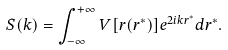<formula> <loc_0><loc_0><loc_500><loc_500>S ( k ) = \int _ { - \infty } ^ { + \infty } V [ r ( r ^ { * } ) ] e ^ { 2 i k r ^ { * } } d r ^ { * } .</formula> 